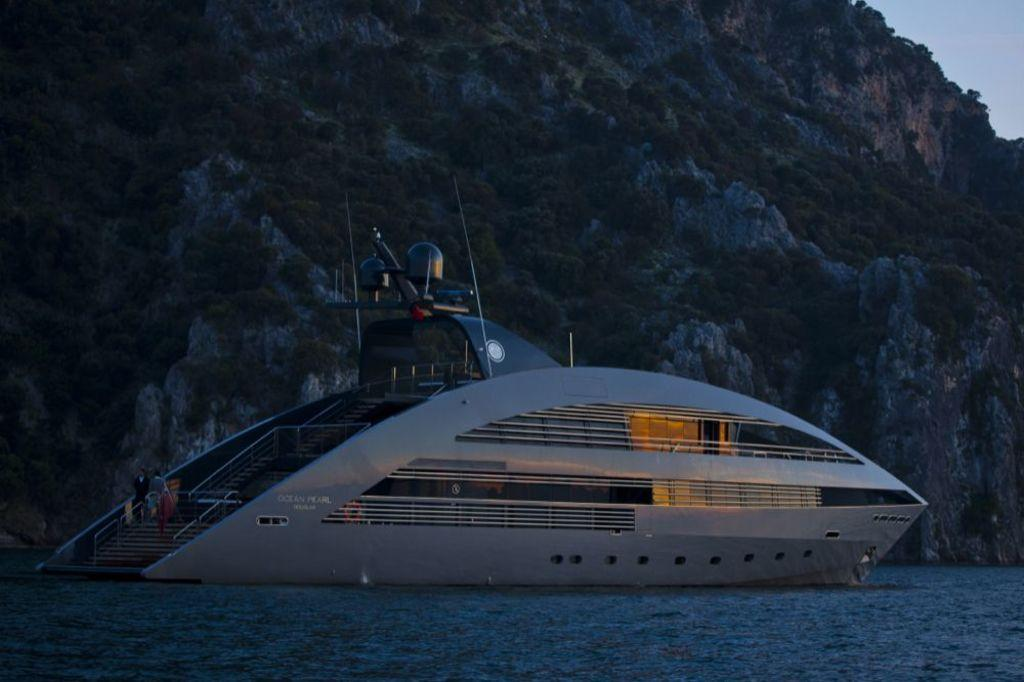What is the main subject of the image? There is a ship in the image. Where is the ship located? The ship is on the water. What can be seen in the background of the image? There are trees on a hill in the background of the image. What is visible at the top of the image? The sky is visible at the top of the image. What is present at the bottom of the image? Water is present at the bottom of the image. How many slaves are visible on the ship in the image? There is no mention of slaves in the image, and therefore no such individuals can be observed. What type of stick is being used by the crew on the ship in the image? There is no stick visible in the image, and no crew members are present to use one. 